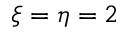Convert formula to latex. <formula><loc_0><loc_0><loc_500><loc_500>\xi = \eta = 2</formula> 